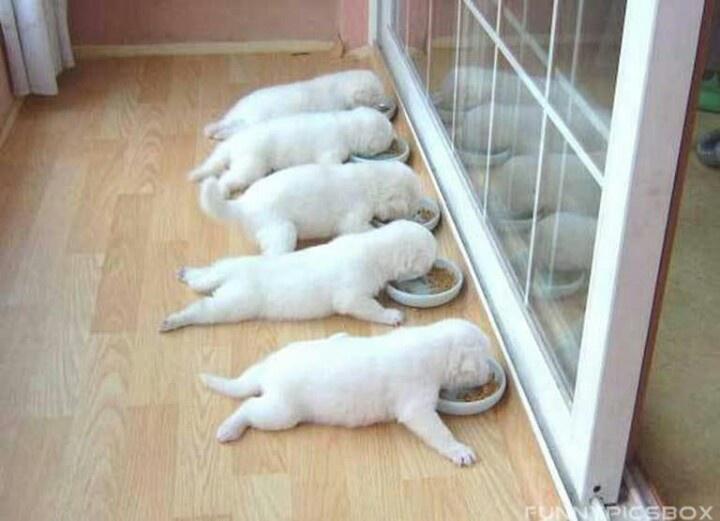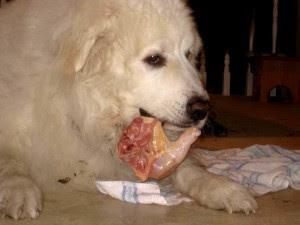The first image is the image on the left, the second image is the image on the right. For the images shown, is this caption "An image shows more than one animal with its face in a round bowl, and at least one of the animals is a white dog." true? Answer yes or no. Yes. The first image is the image on the left, the second image is the image on the right. Analyze the images presented: Is the assertion "The dog in the right image has food in its mouth." valid? Answer yes or no. Yes. 